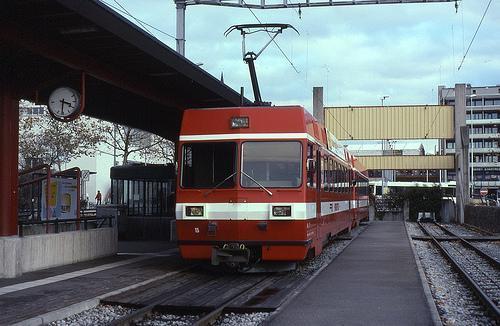How many clocks do you see?
Give a very brief answer. 1. How many trains are there?
Give a very brief answer. 1. 